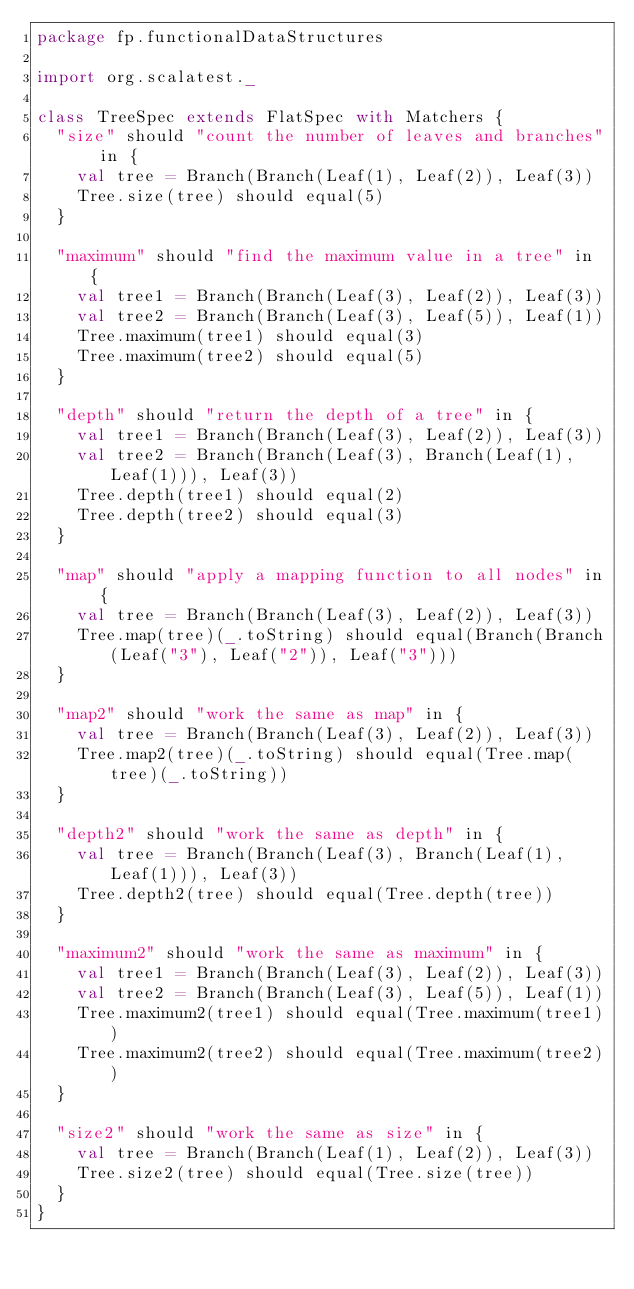Convert code to text. <code><loc_0><loc_0><loc_500><loc_500><_Scala_>package fp.functionalDataStructures

import org.scalatest._

class TreeSpec extends FlatSpec with Matchers {
  "size" should "count the number of leaves and branches" in {
    val tree = Branch(Branch(Leaf(1), Leaf(2)), Leaf(3))
    Tree.size(tree) should equal(5)
  }

  "maximum" should "find the maximum value in a tree" in {
    val tree1 = Branch(Branch(Leaf(3), Leaf(2)), Leaf(3))
    val tree2 = Branch(Branch(Leaf(3), Leaf(5)), Leaf(1))
    Tree.maximum(tree1) should equal(3)
    Tree.maximum(tree2) should equal(5)
  }

  "depth" should "return the depth of a tree" in {
    val tree1 = Branch(Branch(Leaf(3), Leaf(2)), Leaf(3))
    val tree2 = Branch(Branch(Leaf(3), Branch(Leaf(1), Leaf(1))), Leaf(3))
    Tree.depth(tree1) should equal(2)
    Tree.depth(tree2) should equal(3)
  }

  "map" should "apply a mapping function to all nodes" in {
    val tree = Branch(Branch(Leaf(3), Leaf(2)), Leaf(3))
    Tree.map(tree)(_.toString) should equal(Branch(Branch(Leaf("3"), Leaf("2")), Leaf("3")))
  }

  "map2" should "work the same as map" in {
    val tree = Branch(Branch(Leaf(3), Leaf(2)), Leaf(3))
    Tree.map2(tree)(_.toString) should equal(Tree.map(tree)(_.toString))
  }

  "depth2" should "work the same as depth" in {
    val tree = Branch(Branch(Leaf(3), Branch(Leaf(1), Leaf(1))), Leaf(3))
    Tree.depth2(tree) should equal(Tree.depth(tree))
  }

  "maximum2" should "work the same as maximum" in {
    val tree1 = Branch(Branch(Leaf(3), Leaf(2)), Leaf(3))
    val tree2 = Branch(Branch(Leaf(3), Leaf(5)), Leaf(1))
    Tree.maximum2(tree1) should equal(Tree.maximum(tree1))
    Tree.maximum2(tree2) should equal(Tree.maximum(tree2))
  }

  "size2" should "work the same as size" in {
    val tree = Branch(Branch(Leaf(1), Leaf(2)), Leaf(3))
    Tree.size2(tree) should equal(Tree.size(tree))
  }
}

</code> 